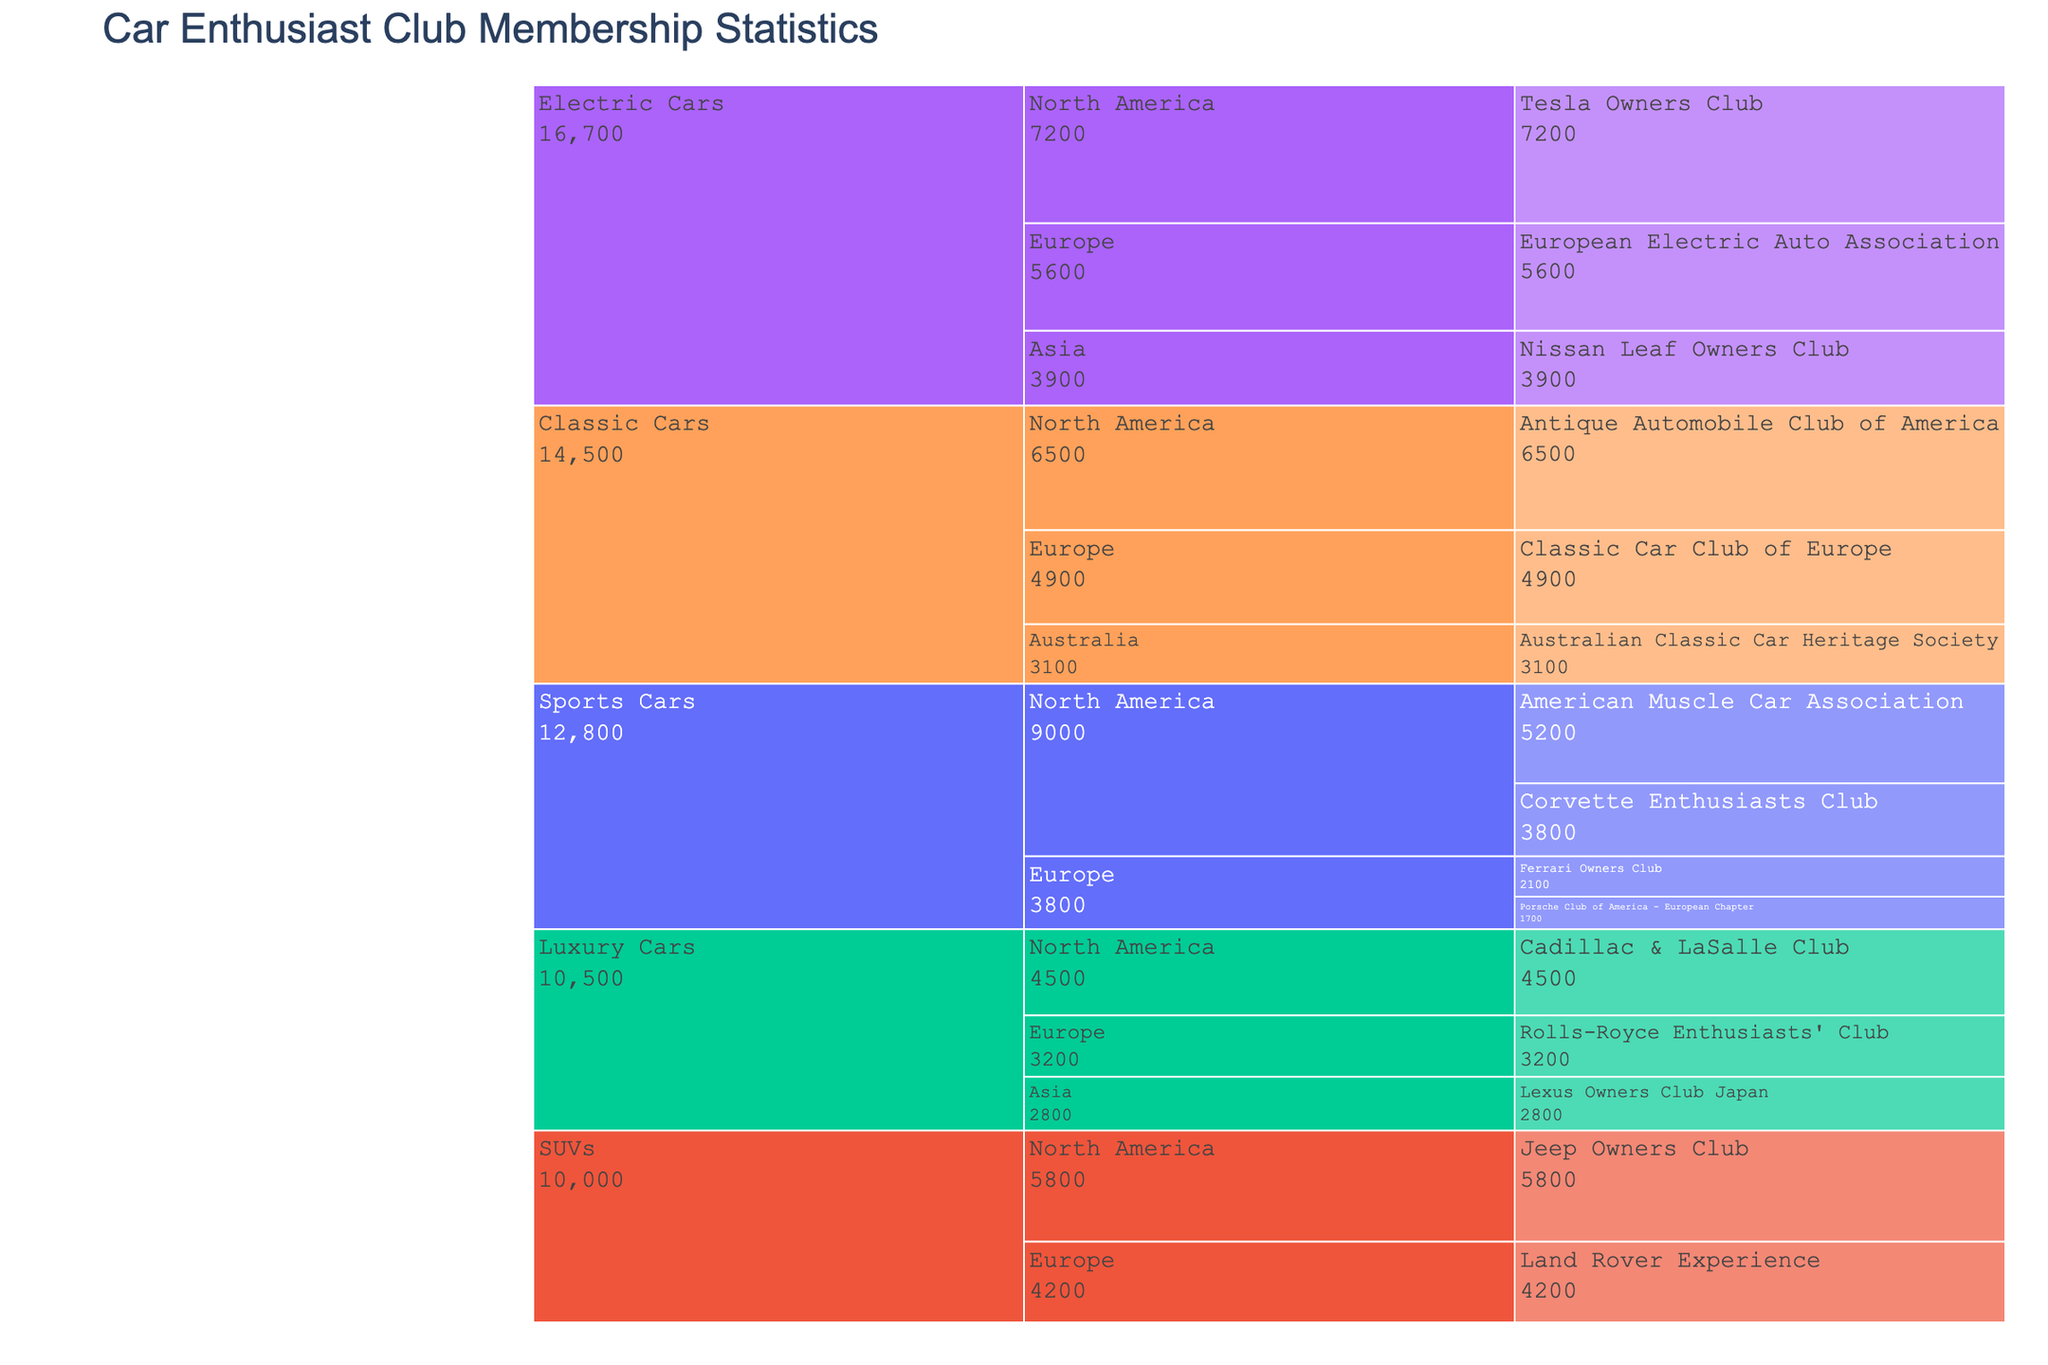What is the title of the figure? The title is usually found at the top of the figure and it provides a clear description of what the figure is about. For this figure, it indicates it's about car enthusiast club membership statistics.
Answer: Car Enthusiast Club Membership Statistics How many members are in the Tesla Owners Club? Look at the corresponding section for the Tesla Owners Club in North America and find the number associated with it.
Answer: 7200 Which car type has the highest number of clubs listed? Visually scan the figure and count the number of clubs listed under each car type: Sports Cars, Luxury Cars, Classic Cars, SUVs, and Electric Cars.
Answer: Sports Cars What is the total number of members for car clubs in Europe? Sum the number of members for all clubs in Europe across different car types: 1700 (Porsche) + 2100 (Ferrari) + 3200 (Rolls-Royce) + 4900 (Classic Car Club) + 4200 (Land Rover) + 5600 (Electric Auto Association).
Answer: 21700 Compare the number of members in the American Muscle Car Association to the European Electric Auto Association. Which has more members? Look at the number of members for American Muscle Car Association (North America) and European Electric Auto Association (Europe) and compare them.
Answer: American Muscle Car Association Which region has the Jeep Owners Club, and how many members does it have? Identify the region that has the Jeep Owners Club and then check the number of members. It is located in North America.
Answer: North America, 5800 Between the Antique Automobile Club of America and the Australian Classic Car Heritage Society, which has more members and by how much? Find the members for both clubs: Antique Automobile Club of America (North America) and Australian Classic Car Heritage Society (Australia). Then, calculate their difference: 6500 - 3100.
Answer: Antique Automobile Club of America by 3400 members In which regions can you find Lexus and Nissan Leaf car clubs, and what are their member counts? Locate the Lexus Owners Club and Nissan Leaf Owners Club on the chart and note the corresponding regions and member counts. Lexus is in Asia and Nissan Leaf is also in Asia.
Answer: Asia, 2800 (Lexus); Asia, 3900 (Nissan Leaf) What is the average number of members in clubs for Luxury Cars? Sum the members of all Luxury Car clubs (4500 + 3200 + 2800) and divide by the number of clubs (3).
Answer: 3500 Identify the club with the smallest number of members and state the car type and region. Look for the club with the smallest membership across all branches of the icicle chart.
Answer: Porsche Club of America - European Chapter, Sports Cars, Europe, 1700 